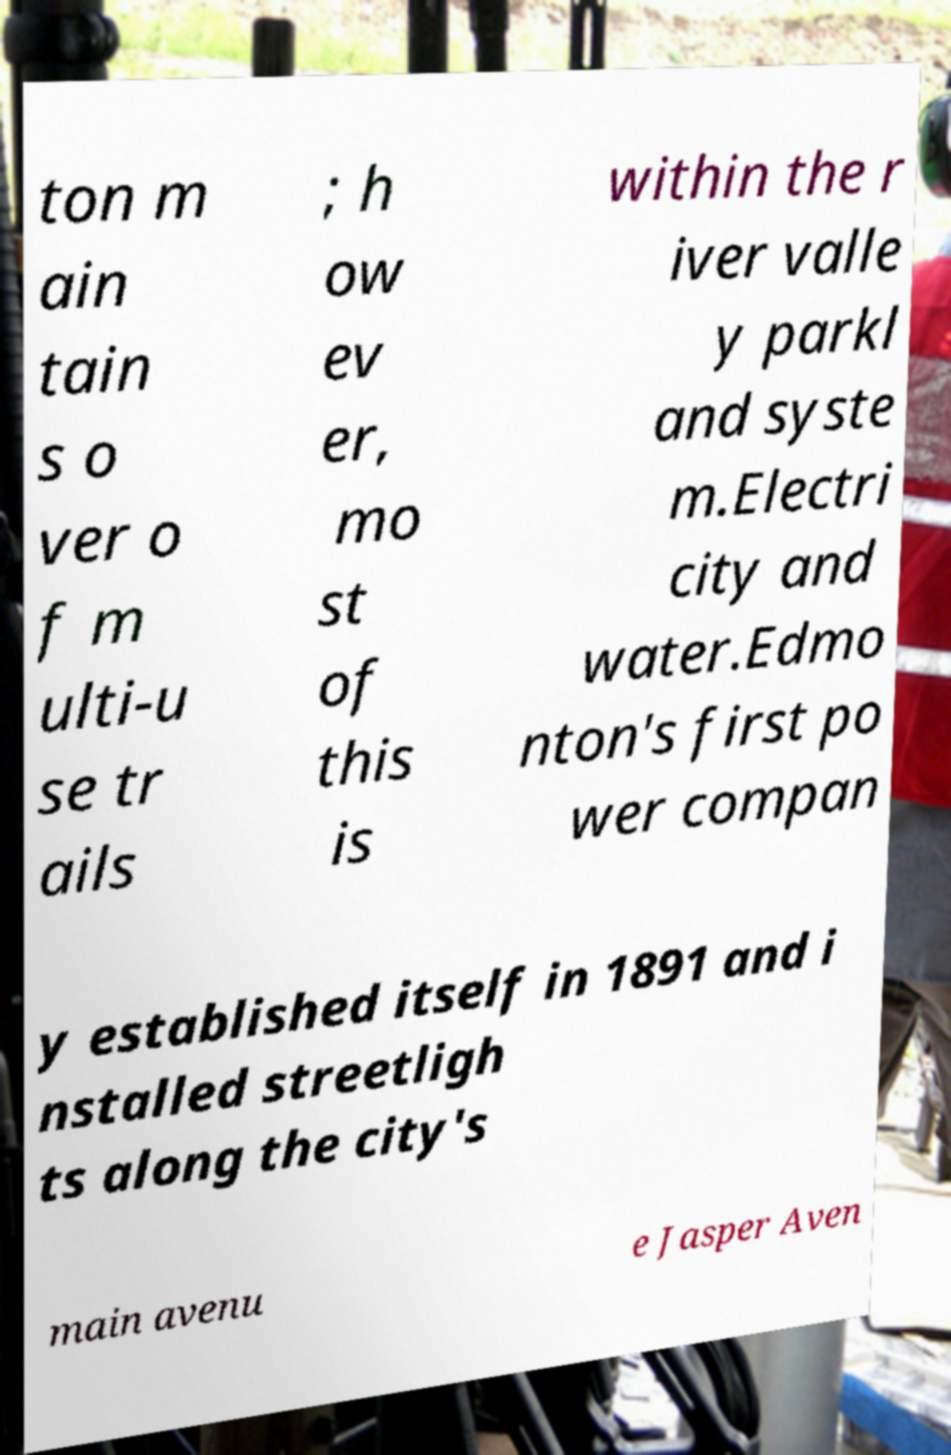Could you extract and type out the text from this image? ton m ain tain s o ver o f m ulti-u se tr ails ; h ow ev er, mo st of this is within the r iver valle y parkl and syste m.Electri city and water.Edmo nton's first po wer compan y established itself in 1891 and i nstalled streetligh ts along the city's main avenu e Jasper Aven 